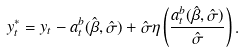<formula> <loc_0><loc_0><loc_500><loc_500>y _ { t } ^ { * } = y _ { t } - a _ { t } ^ { b } ( \hat { \beta } , \hat { \sigma } ) + \hat { \sigma } \eta \left ( \frac { a _ { t } ^ { b } ( \hat { \beta } , \hat { \sigma } ) } { \hat { \sigma } } \right ) .</formula> 